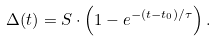<formula> <loc_0><loc_0><loc_500><loc_500>\Delta ( t ) = S \cdot \left ( 1 - e ^ { - ( t - t _ { 0 } ) / \tau } \right ) .</formula> 